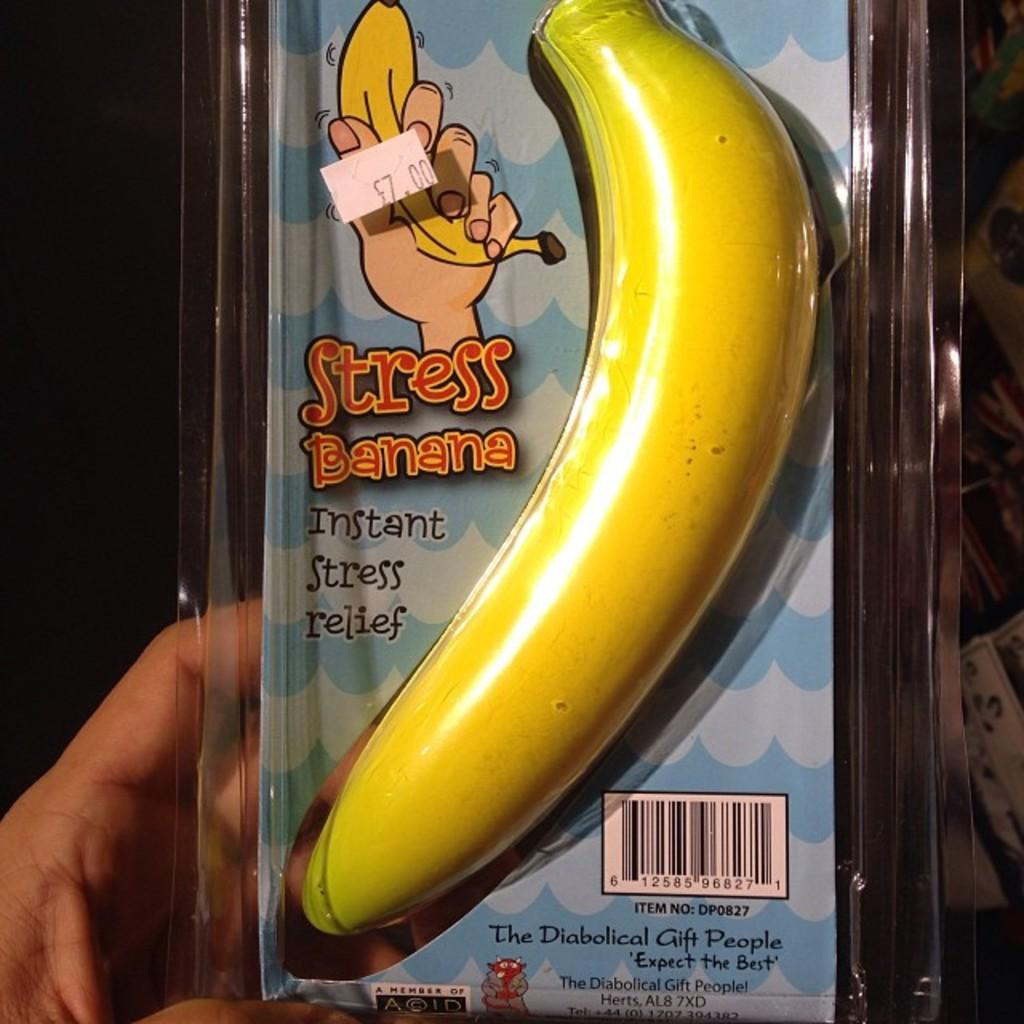What object is featured in the image that is used for stress relief? There is a stress relief banana in the image. How is the stress relief banana packaged? The stress relief banana is packed in a sheet. Who is holding the stress relief banana in the image? The stress relief banana is being held by a person. What can be observed about the background of the image? The background of the image is dark. Can you see any dirt on the kettle in the image? There is no kettle present in the image, so it is not possible to determine if there is any dirt on it. 